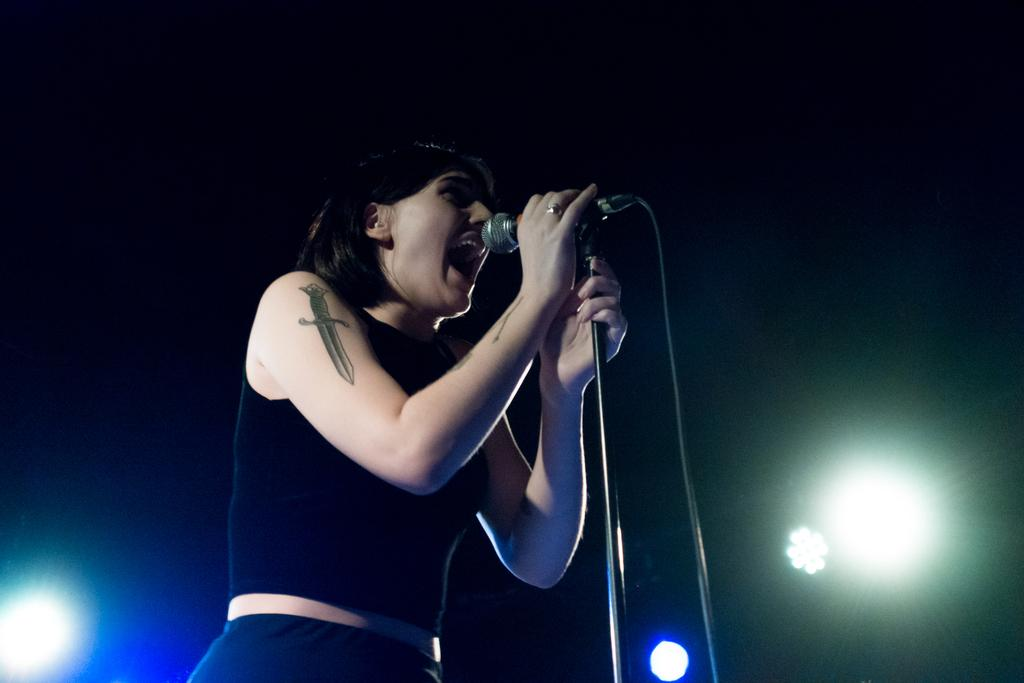Who is the main subject in the image? There is a woman in the image. What is the woman doing in the image? The woman is standing and singing. What is she using to amplify her voice? She is using a microphone. What can be seen in the background of the image? There are lights visible in the image. What type of cord is attached to the microphone in the image? There is no visible cord attached to the microphone in the image. Is there a servant present in the image? There is no servant present in the image. 